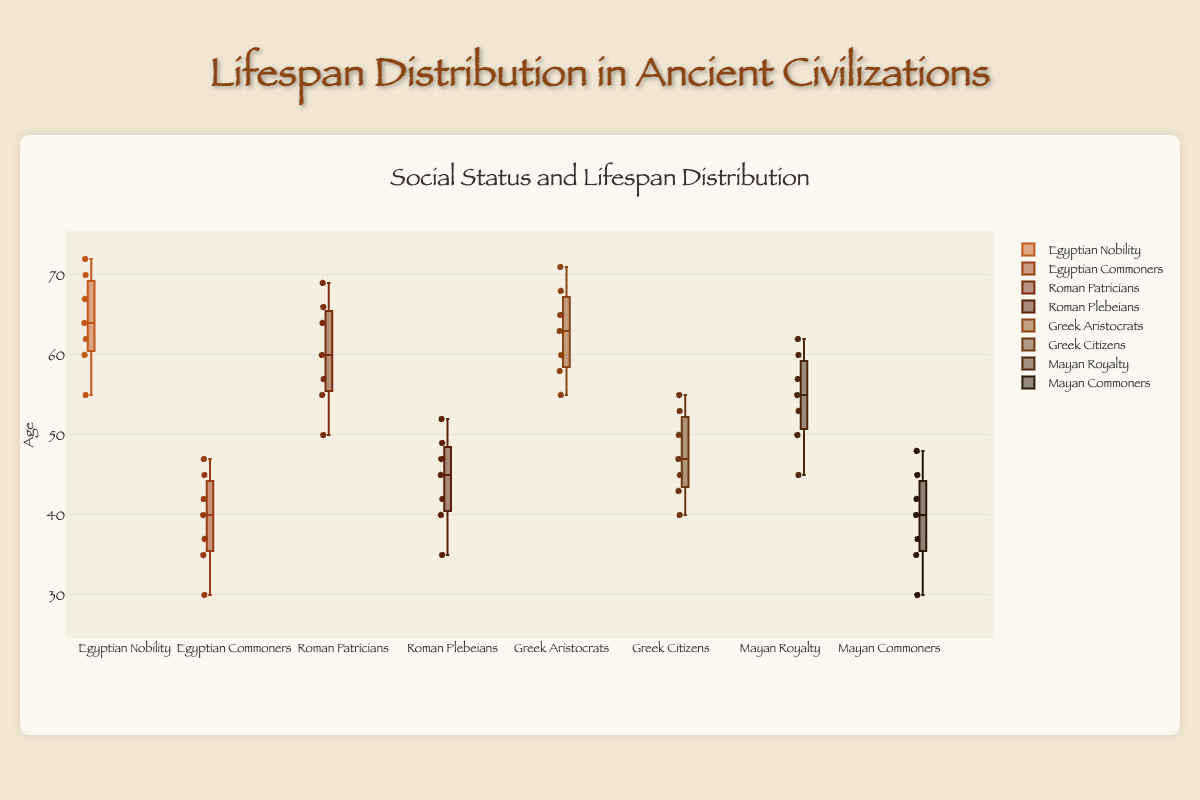How many different groups of people are represented in the box plot? The box plot displays data for Egyptian Nobility, Egyptian Commoners, Roman Patricians, Roman Plebeians, Greek Aristocrats, Greek Citizens, Mayan Royalty, and Mayan Commoners. The total is 8 different groups.
Answer: 8 What is the median lifespan of Egyptian Nobility? The median is the middle value of the sorted data points. For Egyptian Nobility, the sorted data are [55, 60, 62, 64, 67, 70, 72]. The middle value is 64.
Answer: 64 Which group has the highest maximum lifespan? Examine the maximum value for each group. Egyptian Nobility has 72, Egyptian Commoners has 47, Roman Patricians has 69, Roman Plebeians has 52, Greek Aristocrats has 71, Greek Citizens has 55, Mayan Royalty has 62, and Mayan Commoners has 48. The highest maximum value is 72 for Egyptian Nobility.
Answer: Egyptian Nobility What is the range of lifespans for Mayan Commoners? The range is calculated by subtracting the minimum value from the maximum value. For Mayan Commoners, the minimum value is 30 and the maximum value is 48. Range = 48 - 30 = 18.
Answer: 18 Compare the median lifespan of Greek Aristocrats to Greek Citizens. Which is higher, and by how much? Calculate the medians: Greek Aristocrats [55, 58, 60, 63, 65, 68, 71] has a median of 63, Greek Citizens [40, 43, 45, 47, 50, 53, 55] has a median of 47. The difference is 63 - 47 = 16.
Answer: Greek Aristocrats by 16 What is the interquartile range (IQR) for Roman Plebeians? The IQR is the difference between the 75th percentile and the 25th percentile. For Roman Plebeians [35, 40, 42, 45, 47, 49, 52], these are the 1st (25th percentile = 40), 3rd (75th percentile = 49). IQR = 49 - 40 = 9.
Answer: 9 Which group has the smallest median lifespan? Identify the medians: Egyptian Nobility 64, Egyptian Commoners 40, Roman Patricians 60, Roman Plebeians 45, Greek Aristocrats 63, Greek Citizens 47, Mayan Royalty 55, Mayan Commoners 40. Both Egyptian Commoners and Mayan Commoners have the smallest median of 40.
Answer: Egyptian Commoners and Mayan Commoners Compare the interquartile ranges (IQR) of Egyptian Nobility and Roman Patricians and determine which group has a higher IQR. IQR for Egyptian Nobility: data [55, 60, 62, 64, 67, 70, 72] gives Q1=60, Q3=70, so IQR=10. IQR for Roman Patricians: data [50, 55, 57, 60, 64, 66, 69] gives Q1=55, Q3=66, so IQR=11. Roman Patricians have a higher IQR.
Answer: Roman Patricians How are the lifespan distributions visually grouped in the plot? Examine the groupings in terms of social status and civilization: Each civilization has two social status groups (Nobility vs. Commoners, Patricians vs. Plebeians, Aristocrats vs. Citizens, Royalty vs. Commoners). The distributions for each civilization are visually aligned side-by-side for comparison.
Answer: By social status within each civilization 